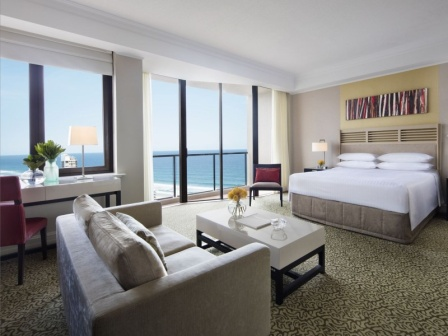How might someone use the different areas of this room throughout their stay? A guest might start their morning enjoying a cup of coffee on the balcony, taking in the ocean view and the fresh sea breeze. Afterward, they could spend some time at the desk by the window, catching up on work or writing postcards. In the afternoon, the cozy gray sofa or the red armchair serve as perfect spots for relaxation, reading a book, or chatting with a travel companion. The bed, with its inviting white linens, guarantees a restful night's sleep. The thoughtfully designed spaces cater to various activities, ensuring a comfortable and satisfying stay. 